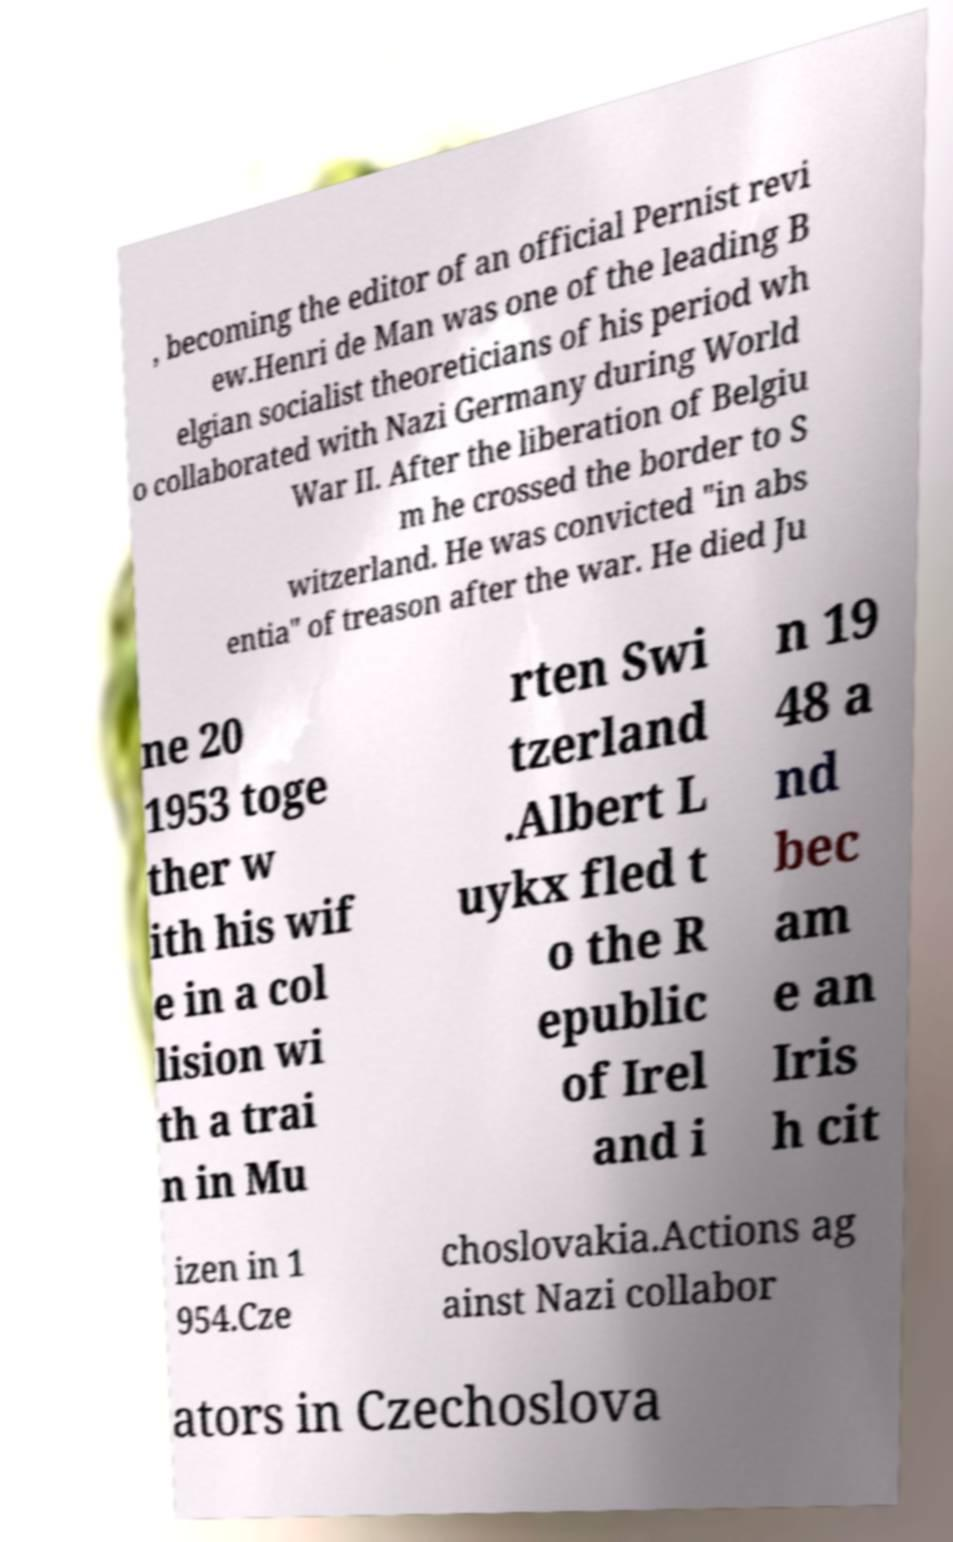Could you assist in decoding the text presented in this image and type it out clearly? , becoming the editor of an official Pernist revi ew.Henri de Man was one of the leading B elgian socialist theoreticians of his period wh o collaborated with Nazi Germany during World War II. After the liberation of Belgiu m he crossed the border to S witzerland. He was convicted "in abs entia" of treason after the war. He died Ju ne 20 1953 toge ther w ith his wif e in a col lision wi th a trai n in Mu rten Swi tzerland .Albert L uykx fled t o the R epublic of Irel and i n 19 48 a nd bec am e an Iris h cit izen in 1 954.Cze choslovakia.Actions ag ainst Nazi collabor ators in Czechoslova 